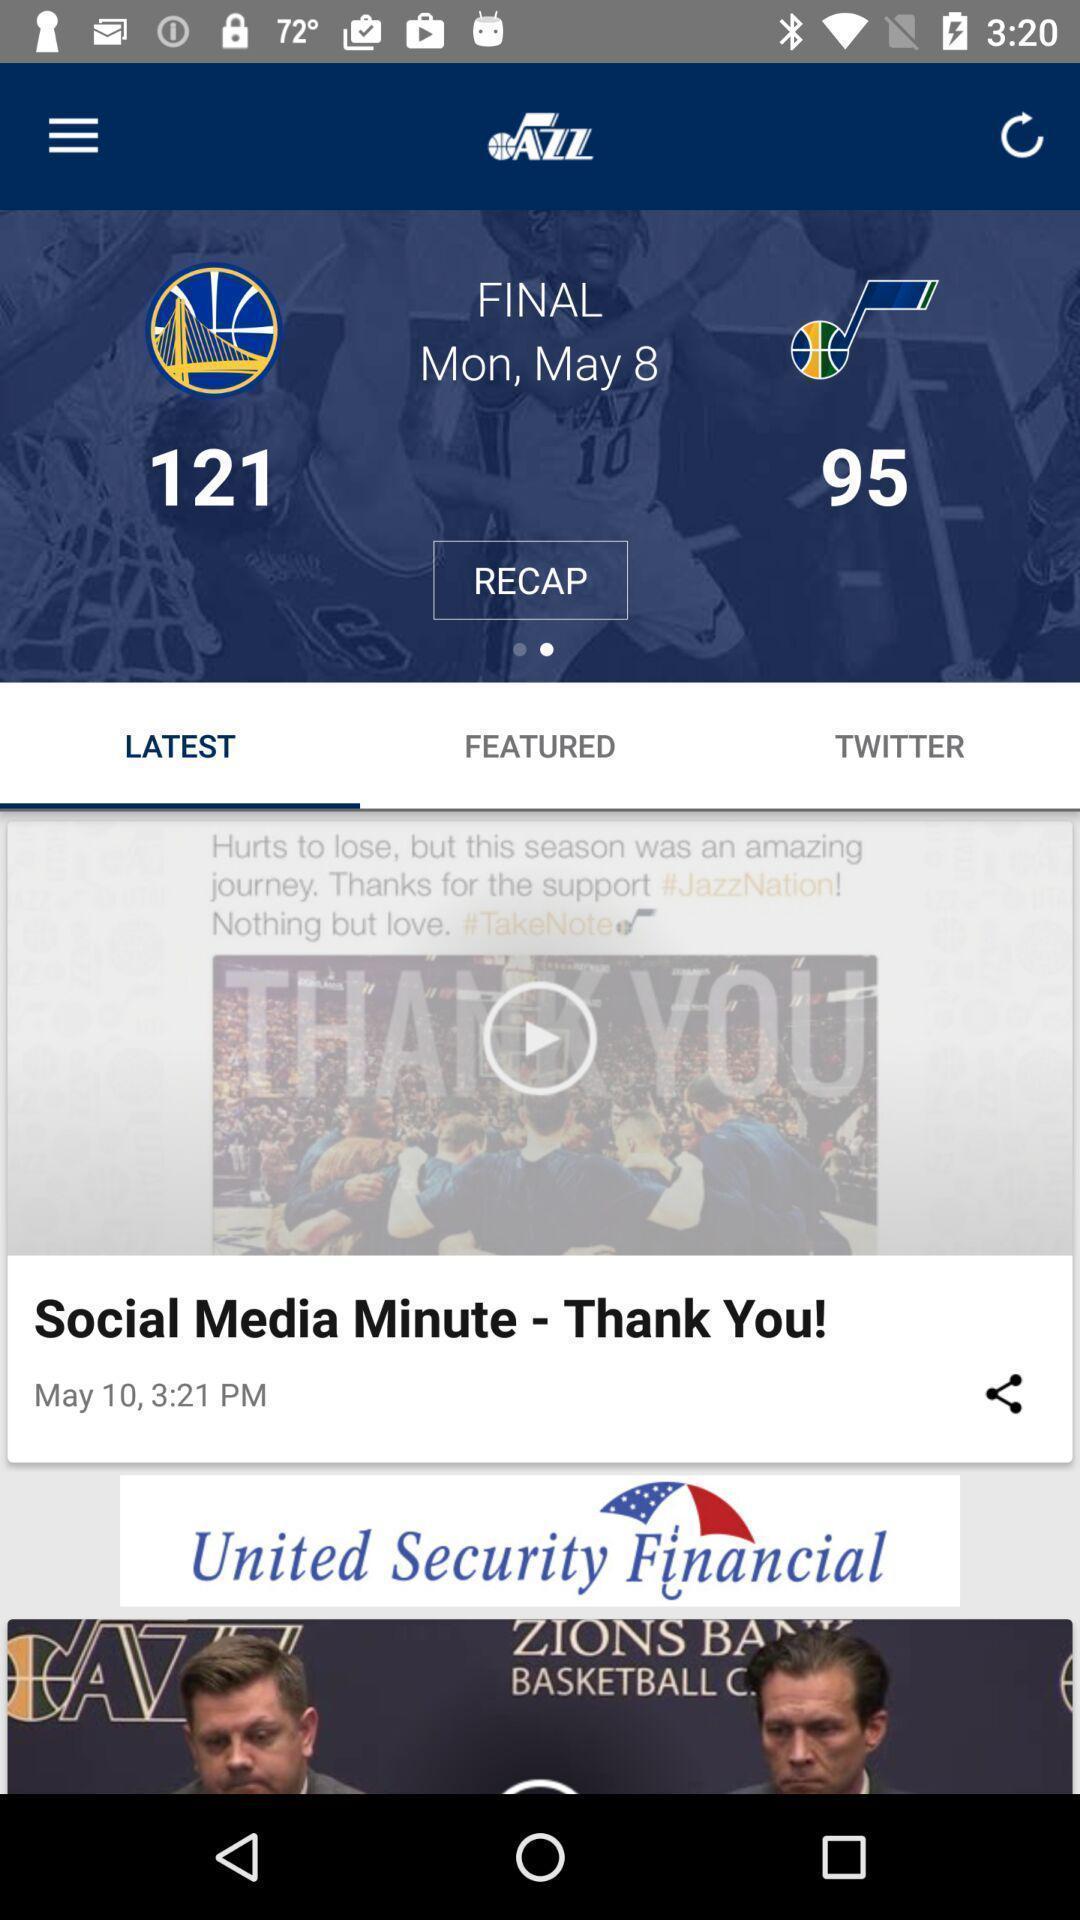What can you discern from this picture? Screen shows latest videos of live news. 